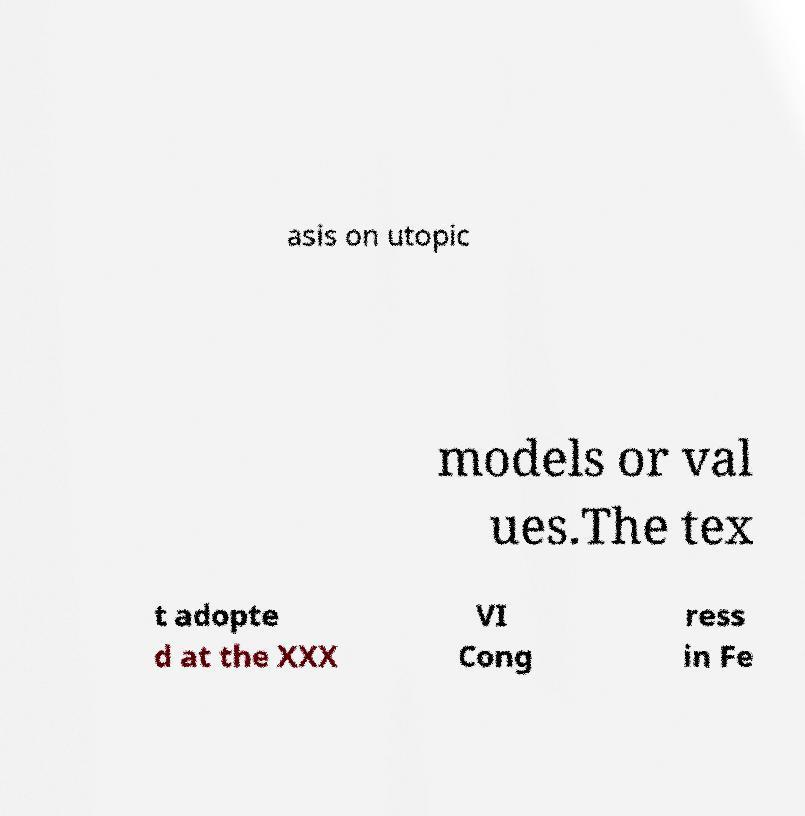Please read and relay the text visible in this image. What does it say? asis on utopic models or val ues.The tex t adopte d at the XXX VI Cong ress in Fe 